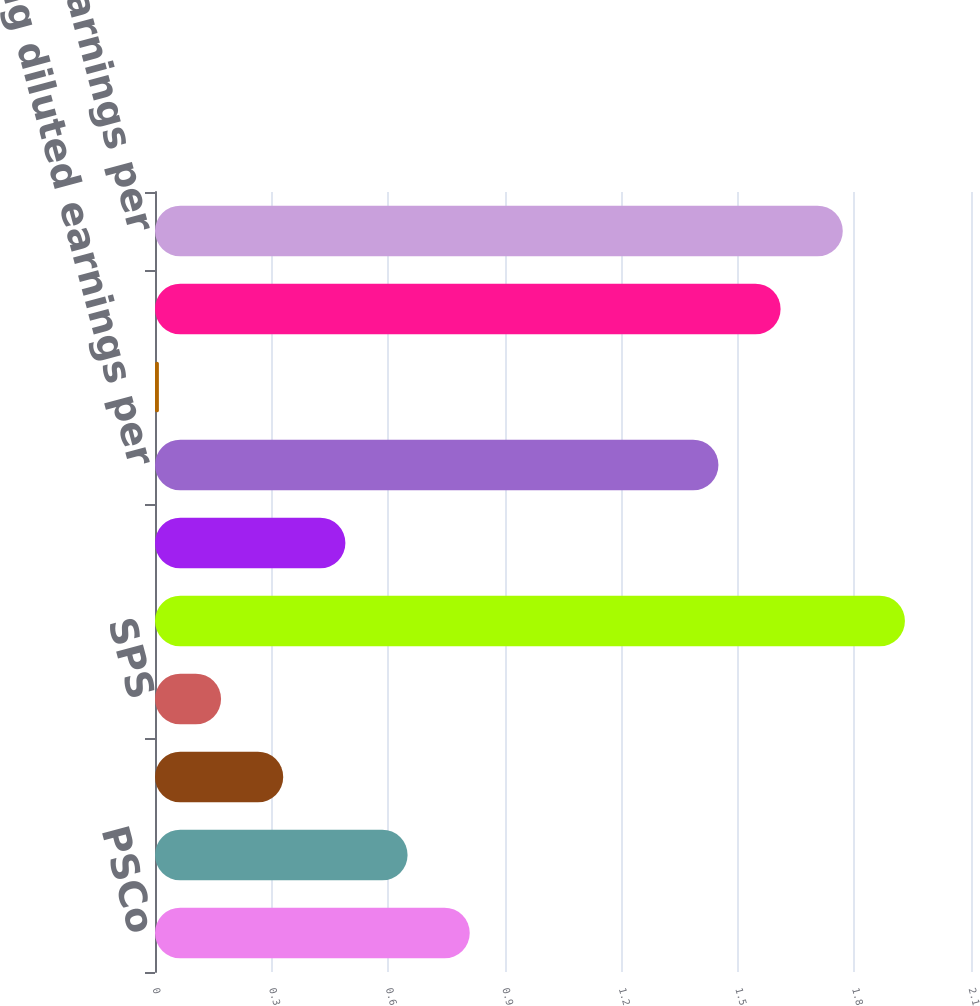Convert chart. <chart><loc_0><loc_0><loc_500><loc_500><bar_chart><fcel>PSCo<fcel>NSP-Minnesota<fcel>NSP-Wisconsin<fcel>SPS<fcel>Regulated utility - continuing<fcel>Holding company and other<fcel>Ongoing diluted earnings per<fcel>PSRI<fcel>Earnings per share -<fcel>GAAP diluted earnings per<nl><fcel>0.81<fcel>0.65<fcel>0.33<fcel>0.17<fcel>1.93<fcel>0.49<fcel>1.45<fcel>0.01<fcel>1.61<fcel>1.77<nl></chart> 